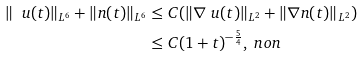<formula> <loc_0><loc_0><loc_500><loc_500>\| \ u ( t ) \| _ { L ^ { 6 } } + \| n ( t ) \| _ { L ^ { 6 } } & \leq C ( \| \nabla \ u ( t ) \| _ { L ^ { 2 } } + \| \nabla n ( t ) \| _ { L ^ { 2 } } ) \\ & \leq C ( 1 + t ) ^ { - \frac { 5 } { 4 } } , \ n o n</formula> 